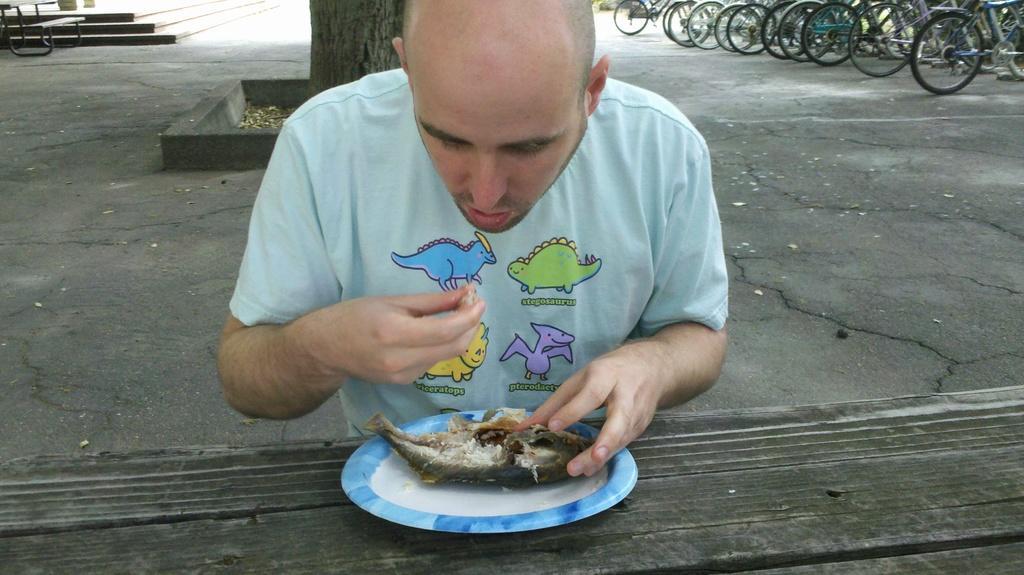In one or two sentences, can you explain what this image depicts? In the center of the image we can see persons sitting at the table. On the table we can see fish on plate. In the background we can see cycles, tree and stairs. 